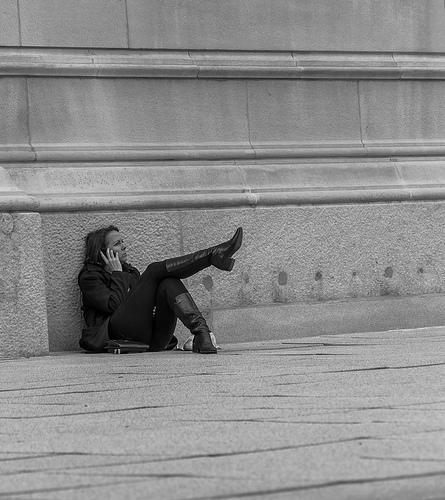How many people are in the photo?
Give a very brief answer. 1. 